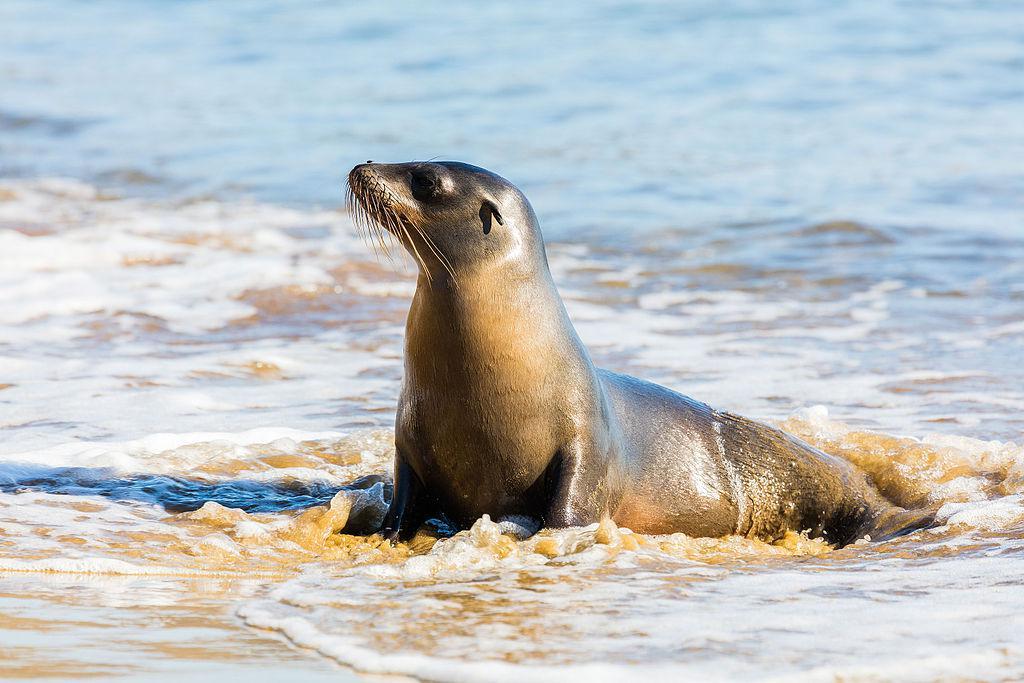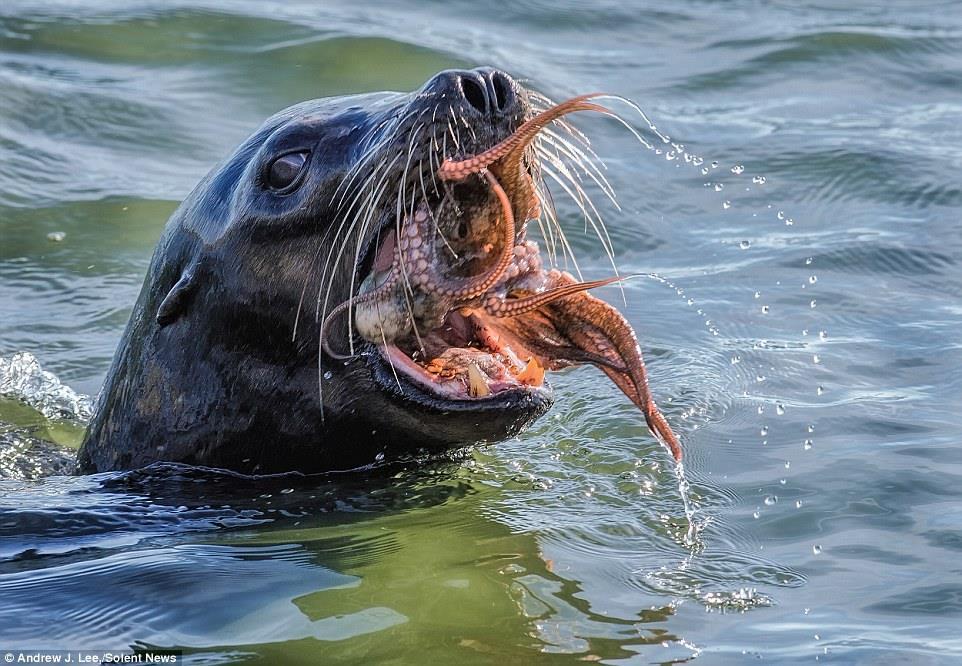The first image is the image on the left, the second image is the image on the right. For the images displayed, is the sentence "The mouth of the seal in one of the images is open." factually correct? Answer yes or no. Yes. 